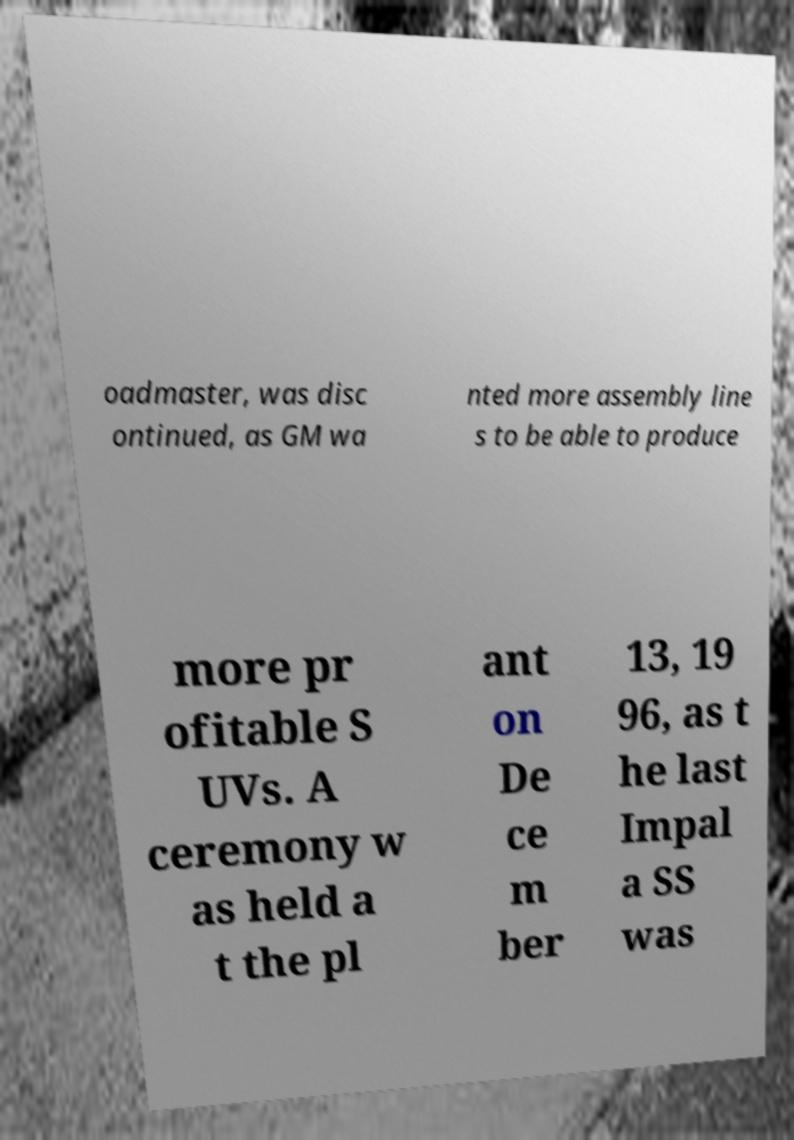Please read and relay the text visible in this image. What does it say? oadmaster, was disc ontinued, as GM wa nted more assembly line s to be able to produce more pr ofitable S UVs. A ceremony w as held a t the pl ant on De ce m ber 13, 19 96, as t he last Impal a SS was 